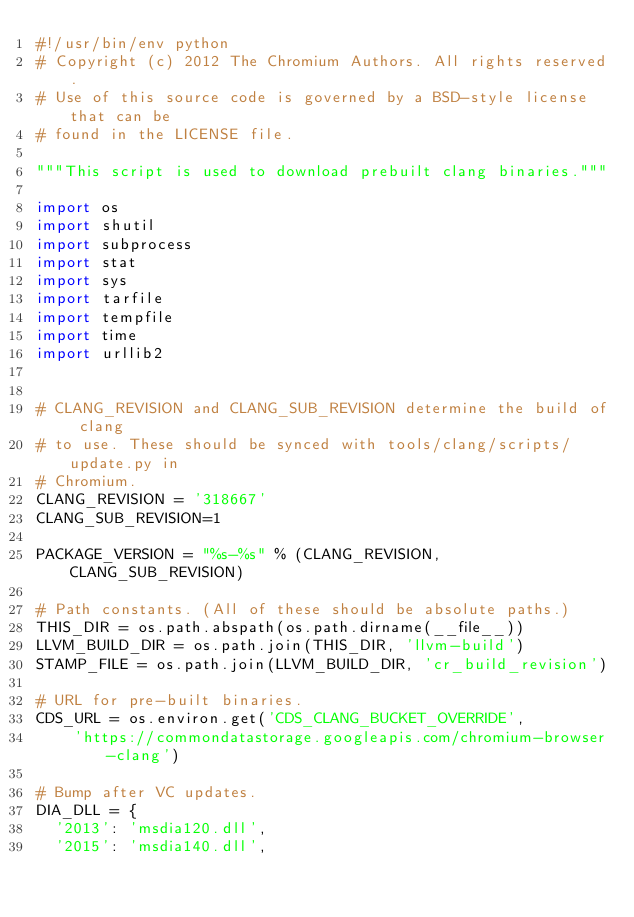<code> <loc_0><loc_0><loc_500><loc_500><_Python_>#!/usr/bin/env python
# Copyright (c) 2012 The Chromium Authors. All rights reserved.
# Use of this source code is governed by a BSD-style license that can be
# found in the LICENSE file.

"""This script is used to download prebuilt clang binaries."""

import os
import shutil
import subprocess
import stat
import sys
import tarfile
import tempfile
import time
import urllib2


# CLANG_REVISION and CLANG_SUB_REVISION determine the build of clang
# to use. These should be synced with tools/clang/scripts/update.py in
# Chromium.
CLANG_REVISION = '318667'
CLANG_SUB_REVISION=1

PACKAGE_VERSION = "%s-%s" % (CLANG_REVISION, CLANG_SUB_REVISION)

# Path constants. (All of these should be absolute paths.)
THIS_DIR = os.path.abspath(os.path.dirname(__file__))
LLVM_BUILD_DIR = os.path.join(THIS_DIR, 'llvm-build')
STAMP_FILE = os.path.join(LLVM_BUILD_DIR, 'cr_build_revision')

# URL for pre-built binaries.
CDS_URL = os.environ.get('CDS_CLANG_BUCKET_OVERRIDE',
    'https://commondatastorage.googleapis.com/chromium-browser-clang')

# Bump after VC updates.
DIA_DLL = {
  '2013': 'msdia120.dll',
  '2015': 'msdia140.dll',</code> 